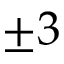Convert formula to latex. <formula><loc_0><loc_0><loc_500><loc_500>\pm 3</formula> 